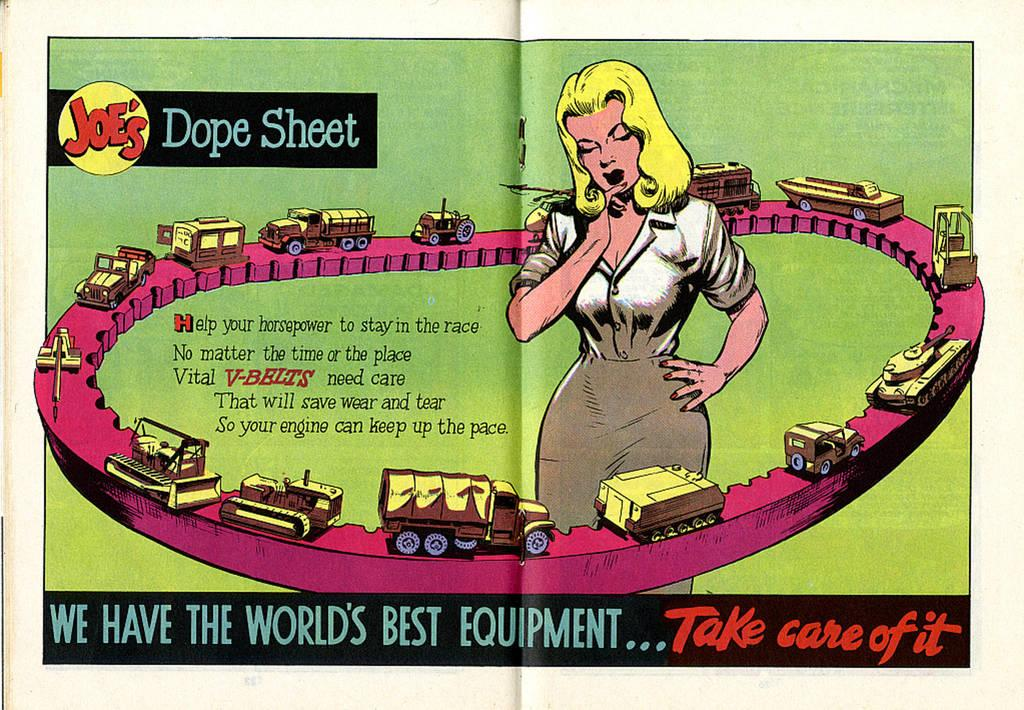<image>
Describe the image concisely. A magazine centerfold is open displaying a colorful cartoon called Joe's Dope Sheet. 